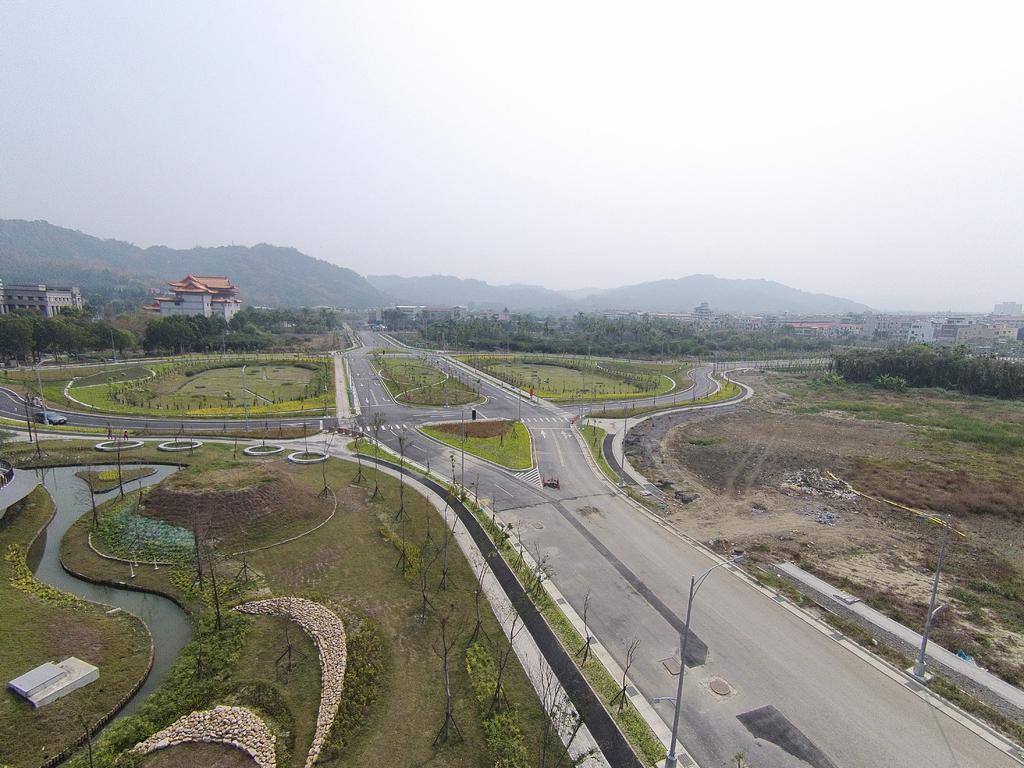In one or two sentences, can you explain what this image depicts? In this picture we can see the road, here we can see trees, poles, water, vehicle and some objects and in the background we can see buildings, mountains, sky. 